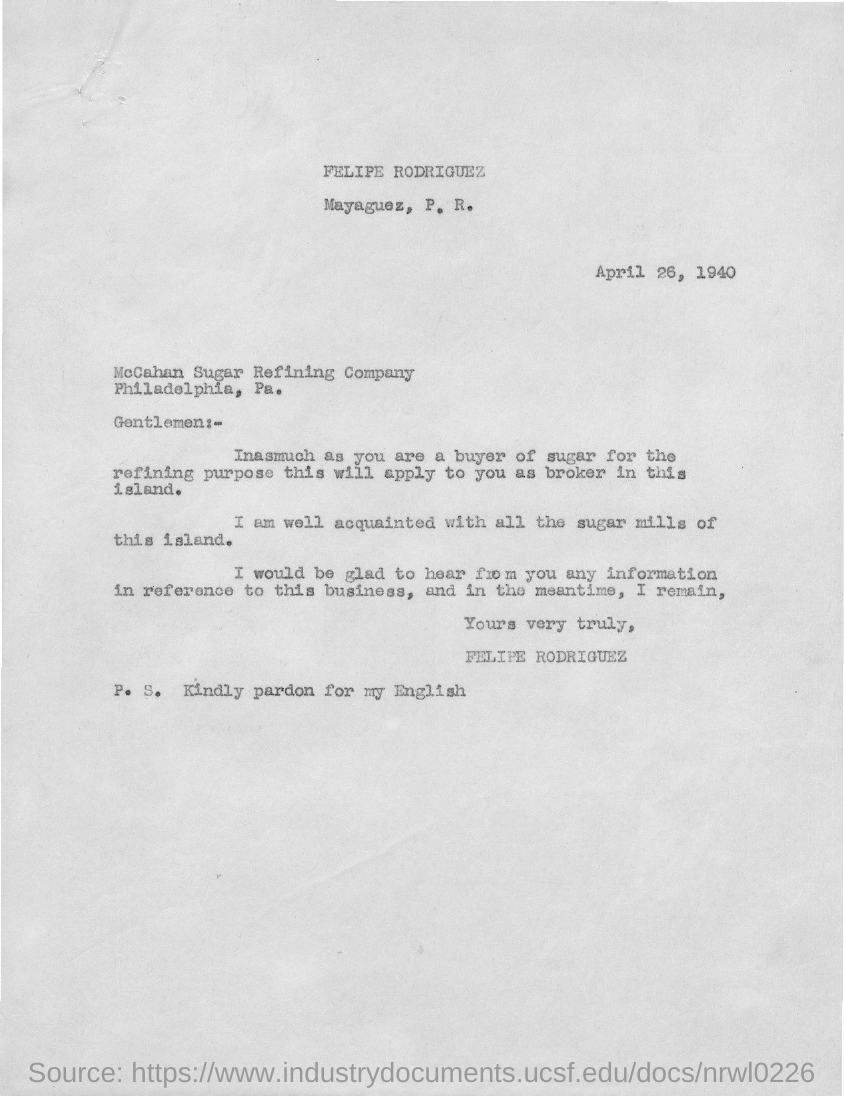What is the date mentioned in this letter?
Your answer should be very brief. April 26, 1940. 